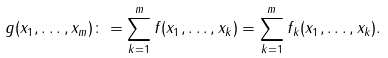<formula> <loc_0><loc_0><loc_500><loc_500>g ( x _ { 1 } , \dots , x _ { m } ) \colon = \sum _ { k = 1 } ^ { m } f ( x _ { 1 } , \dots , x _ { k } ) = \sum _ { k = 1 } ^ { m } f _ { k } ( x _ { 1 } , \dots , x _ { k } ) .</formula> 